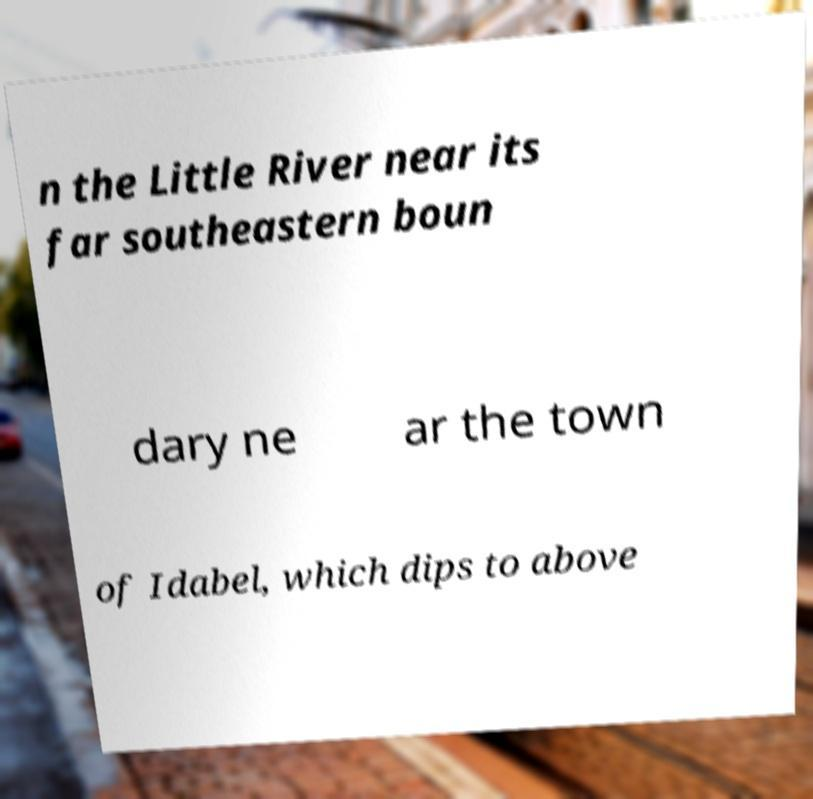I need the written content from this picture converted into text. Can you do that? n the Little River near its far southeastern boun dary ne ar the town of Idabel, which dips to above 